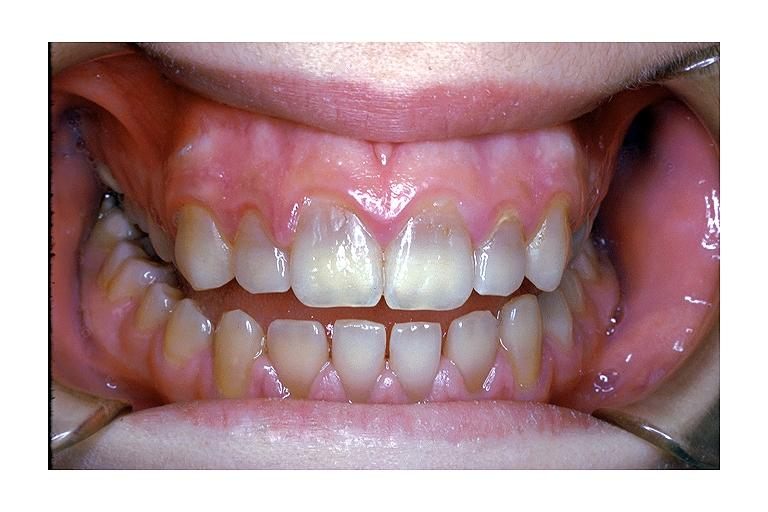does carcinoma metastatic lung show tetracycline induced discoloration?
Answer the question using a single word or phrase. No 